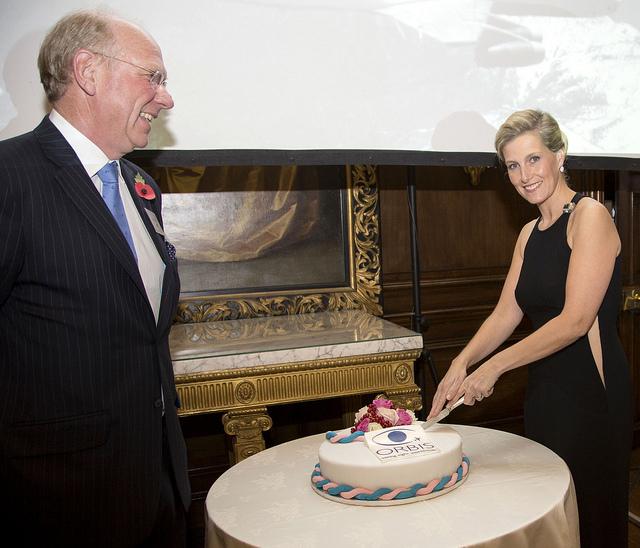Does the woman's dress have sleeves?
Concise answer only. No. What is this couple celebrating?
Keep it brief. Anniversary. What is the tabletop made of next to the wall?
Write a very short answer. Marble. What is in the woman's hand?
Be succinct. Knife. 